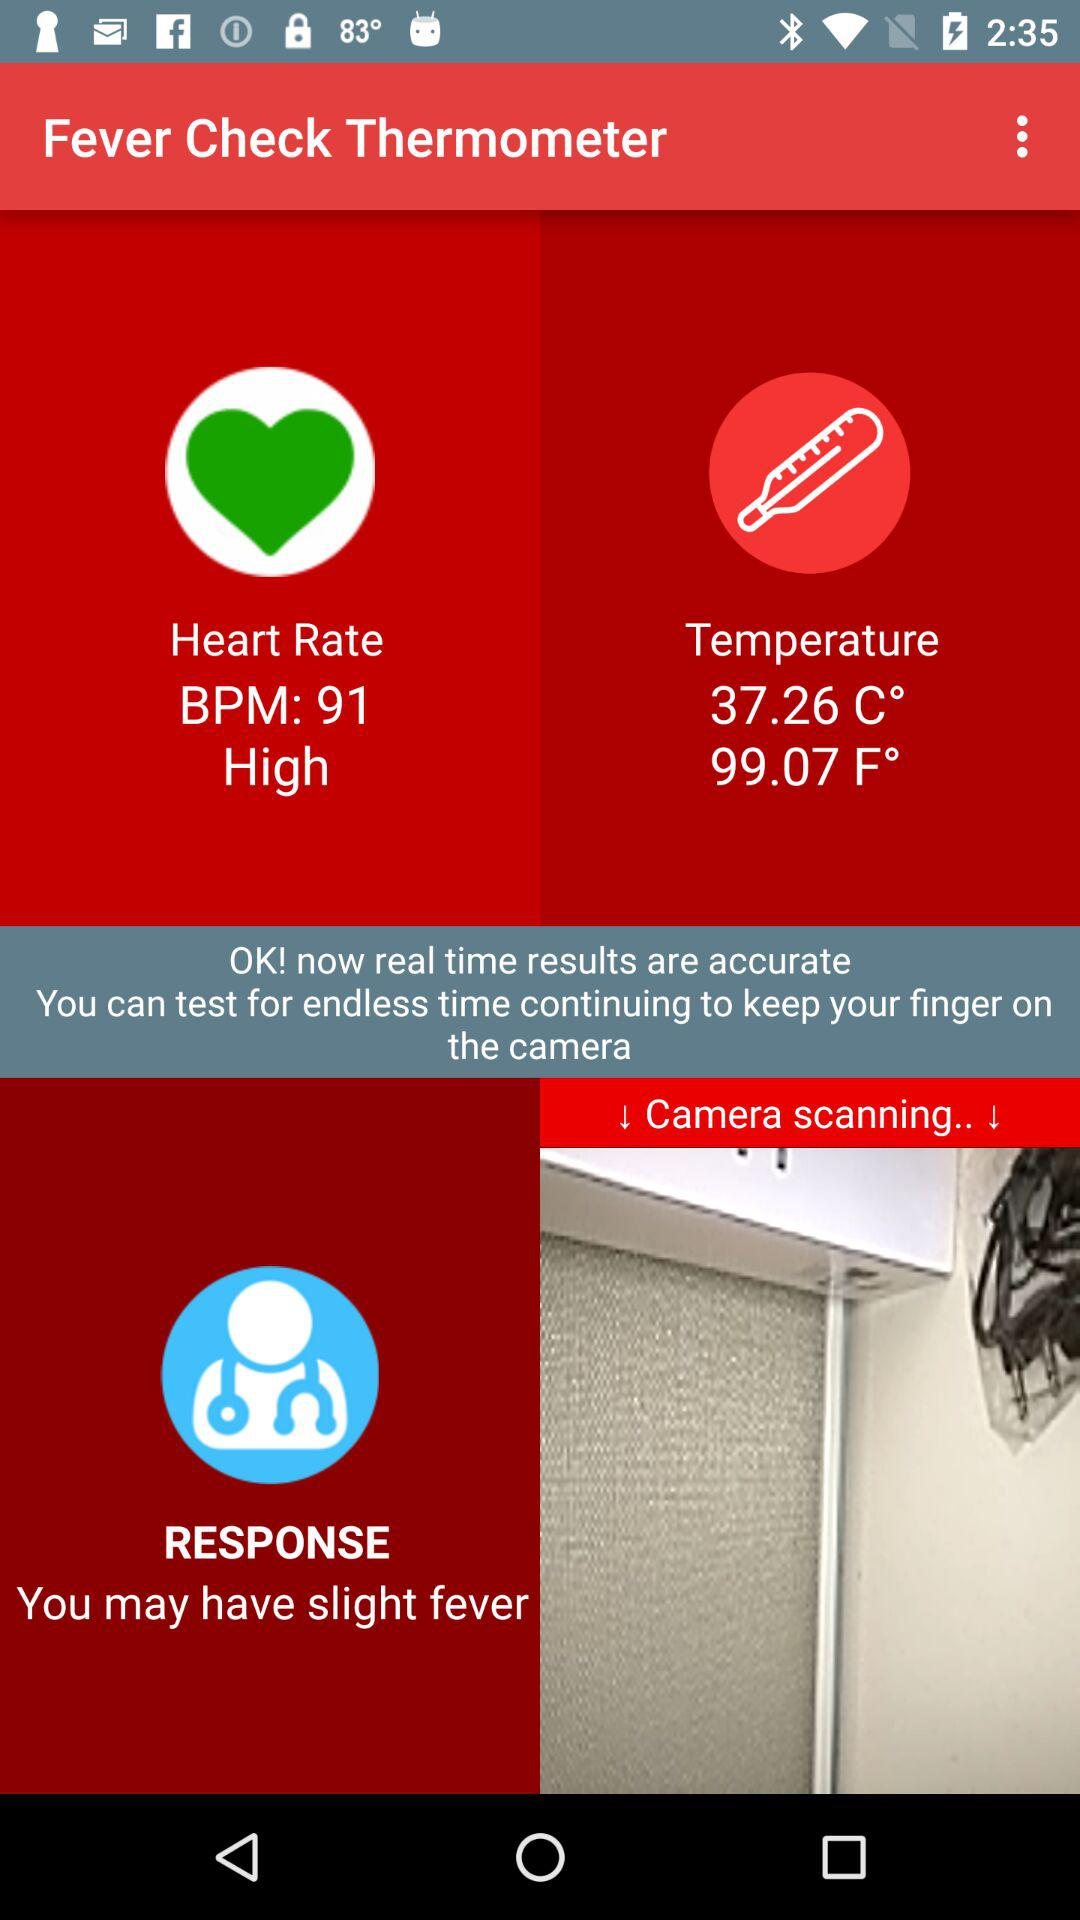How many degrees Fahrenheit is the temperature?
Answer the question using a single word or phrase. 99.07 